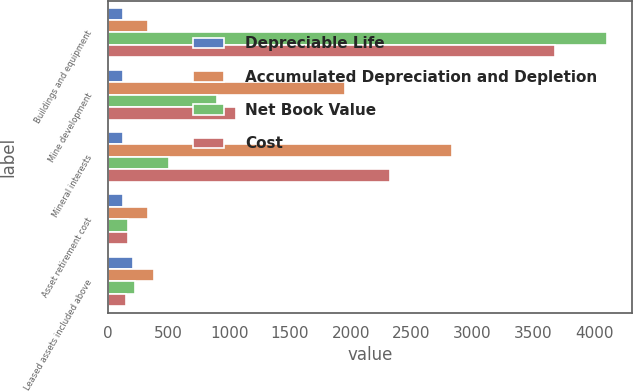Convert chart. <chart><loc_0><loc_0><loc_500><loc_500><stacked_bar_chart><ecel><fcel>Buildings and equipment<fcel>Mine development<fcel>Mineral interests<fcel>Asset retirement cost<fcel>Leased assets included above<nl><fcel>Depreciable Life<fcel>125<fcel>125<fcel>125<fcel>125<fcel>211<nl><fcel>Accumulated Depreciation and Depletion<fcel>335<fcel>1951<fcel>2830<fcel>335<fcel>378<nl><fcel>Net Book Value<fcel>4110<fcel>896<fcel>509<fcel>165<fcel>228<nl><fcel>Cost<fcel>3676<fcel>1055<fcel>2321<fcel>170<fcel>150<nl></chart> 